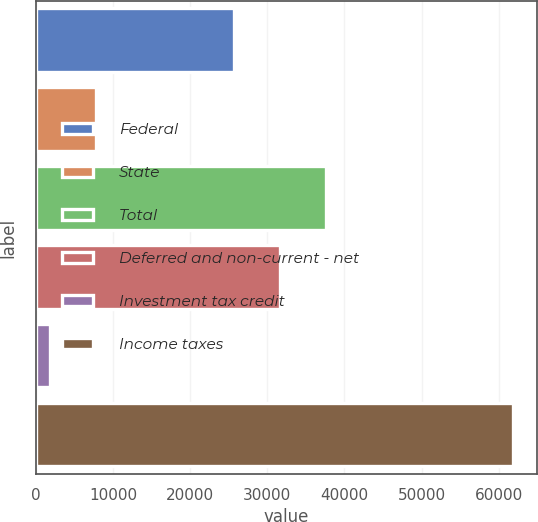<chart> <loc_0><loc_0><loc_500><loc_500><bar_chart><fcel>Federal<fcel>State<fcel>Total<fcel>Deferred and non-current - net<fcel>Investment tax credit<fcel>Income taxes<nl><fcel>25628<fcel>7750.5<fcel>37655<fcel>31641.5<fcel>1737<fcel>61872<nl></chart> 